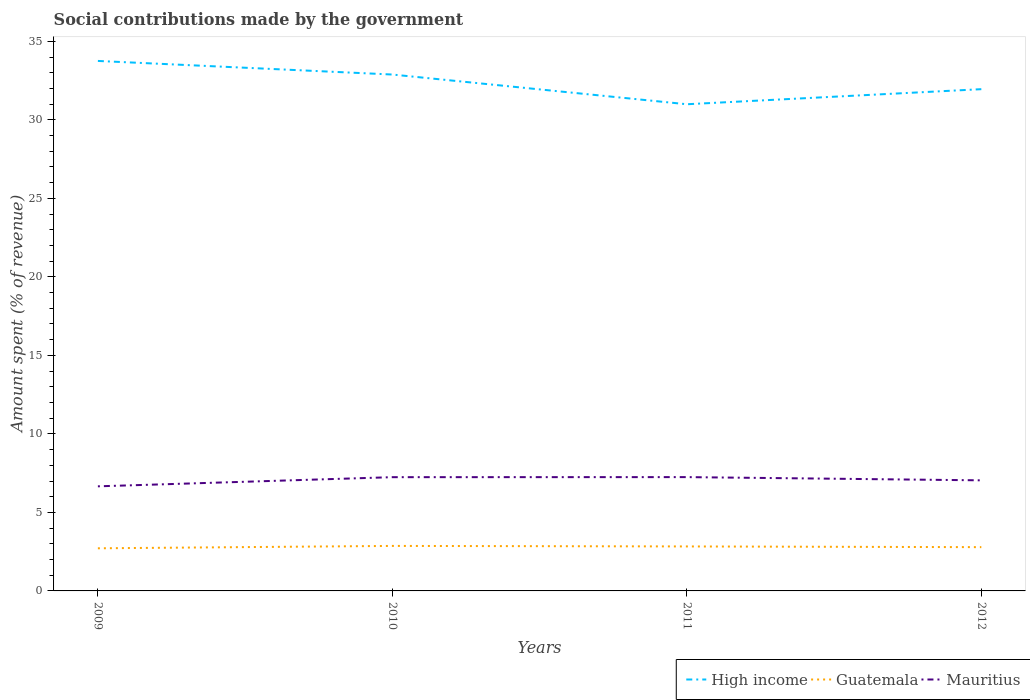Across all years, what is the maximum amount spent (in %) on social contributions in High income?
Your answer should be very brief. 31. In which year was the amount spent (in %) on social contributions in Guatemala maximum?
Offer a terse response. 2009. What is the total amount spent (in %) on social contributions in Mauritius in the graph?
Keep it short and to the point. -0.58. What is the difference between the highest and the second highest amount spent (in %) on social contributions in Mauritius?
Offer a terse response. 0.59. How many lines are there?
Your answer should be very brief. 3. How many years are there in the graph?
Offer a terse response. 4. What is the title of the graph?
Offer a terse response. Social contributions made by the government. Does "Sao Tome and Principe" appear as one of the legend labels in the graph?
Your response must be concise. No. What is the label or title of the Y-axis?
Provide a short and direct response. Amount spent (% of revenue). What is the Amount spent (% of revenue) in High income in 2009?
Offer a terse response. 33.75. What is the Amount spent (% of revenue) in Guatemala in 2009?
Make the answer very short. 2.71. What is the Amount spent (% of revenue) in Mauritius in 2009?
Provide a short and direct response. 6.66. What is the Amount spent (% of revenue) of High income in 2010?
Provide a short and direct response. 32.89. What is the Amount spent (% of revenue) of Guatemala in 2010?
Offer a terse response. 2.87. What is the Amount spent (% of revenue) in Mauritius in 2010?
Your answer should be very brief. 7.24. What is the Amount spent (% of revenue) of High income in 2011?
Offer a very short reply. 31. What is the Amount spent (% of revenue) in Guatemala in 2011?
Keep it short and to the point. 2.83. What is the Amount spent (% of revenue) in Mauritius in 2011?
Make the answer very short. 7.25. What is the Amount spent (% of revenue) of High income in 2012?
Keep it short and to the point. 31.96. What is the Amount spent (% of revenue) in Guatemala in 2012?
Ensure brevity in your answer.  2.79. What is the Amount spent (% of revenue) of Mauritius in 2012?
Offer a terse response. 7.04. Across all years, what is the maximum Amount spent (% of revenue) in High income?
Your answer should be compact. 33.75. Across all years, what is the maximum Amount spent (% of revenue) of Guatemala?
Your answer should be compact. 2.87. Across all years, what is the maximum Amount spent (% of revenue) in Mauritius?
Give a very brief answer. 7.25. Across all years, what is the minimum Amount spent (% of revenue) of High income?
Give a very brief answer. 31. Across all years, what is the minimum Amount spent (% of revenue) of Guatemala?
Ensure brevity in your answer.  2.71. Across all years, what is the minimum Amount spent (% of revenue) of Mauritius?
Your answer should be compact. 6.66. What is the total Amount spent (% of revenue) in High income in the graph?
Offer a very short reply. 129.59. What is the total Amount spent (% of revenue) in Guatemala in the graph?
Your answer should be compact. 11.2. What is the total Amount spent (% of revenue) of Mauritius in the graph?
Your answer should be compact. 28.2. What is the difference between the Amount spent (% of revenue) in High income in 2009 and that in 2010?
Provide a short and direct response. 0.87. What is the difference between the Amount spent (% of revenue) of Guatemala in 2009 and that in 2010?
Make the answer very short. -0.15. What is the difference between the Amount spent (% of revenue) of Mauritius in 2009 and that in 2010?
Give a very brief answer. -0.58. What is the difference between the Amount spent (% of revenue) in High income in 2009 and that in 2011?
Your answer should be compact. 2.76. What is the difference between the Amount spent (% of revenue) in Guatemala in 2009 and that in 2011?
Offer a terse response. -0.12. What is the difference between the Amount spent (% of revenue) of Mauritius in 2009 and that in 2011?
Give a very brief answer. -0.59. What is the difference between the Amount spent (% of revenue) in High income in 2009 and that in 2012?
Your response must be concise. 1.8. What is the difference between the Amount spent (% of revenue) of Guatemala in 2009 and that in 2012?
Your answer should be very brief. -0.07. What is the difference between the Amount spent (% of revenue) of Mauritius in 2009 and that in 2012?
Your answer should be compact. -0.38. What is the difference between the Amount spent (% of revenue) of High income in 2010 and that in 2011?
Provide a succinct answer. 1.89. What is the difference between the Amount spent (% of revenue) of Guatemala in 2010 and that in 2011?
Your answer should be very brief. 0.03. What is the difference between the Amount spent (% of revenue) in Mauritius in 2010 and that in 2011?
Provide a succinct answer. -0. What is the difference between the Amount spent (% of revenue) of High income in 2010 and that in 2012?
Your answer should be very brief. 0.93. What is the difference between the Amount spent (% of revenue) in Guatemala in 2010 and that in 2012?
Your response must be concise. 0.08. What is the difference between the Amount spent (% of revenue) of Mauritius in 2010 and that in 2012?
Provide a short and direct response. 0.2. What is the difference between the Amount spent (% of revenue) in High income in 2011 and that in 2012?
Give a very brief answer. -0.96. What is the difference between the Amount spent (% of revenue) in Guatemala in 2011 and that in 2012?
Make the answer very short. 0.05. What is the difference between the Amount spent (% of revenue) of Mauritius in 2011 and that in 2012?
Provide a short and direct response. 0.21. What is the difference between the Amount spent (% of revenue) in High income in 2009 and the Amount spent (% of revenue) in Guatemala in 2010?
Provide a short and direct response. 30.89. What is the difference between the Amount spent (% of revenue) of High income in 2009 and the Amount spent (% of revenue) of Mauritius in 2010?
Your response must be concise. 26.51. What is the difference between the Amount spent (% of revenue) of Guatemala in 2009 and the Amount spent (% of revenue) of Mauritius in 2010?
Keep it short and to the point. -4.53. What is the difference between the Amount spent (% of revenue) of High income in 2009 and the Amount spent (% of revenue) of Guatemala in 2011?
Provide a succinct answer. 30.92. What is the difference between the Amount spent (% of revenue) in High income in 2009 and the Amount spent (% of revenue) in Mauritius in 2011?
Offer a terse response. 26.51. What is the difference between the Amount spent (% of revenue) of Guatemala in 2009 and the Amount spent (% of revenue) of Mauritius in 2011?
Keep it short and to the point. -4.53. What is the difference between the Amount spent (% of revenue) of High income in 2009 and the Amount spent (% of revenue) of Guatemala in 2012?
Provide a succinct answer. 30.97. What is the difference between the Amount spent (% of revenue) in High income in 2009 and the Amount spent (% of revenue) in Mauritius in 2012?
Offer a terse response. 26.71. What is the difference between the Amount spent (% of revenue) in Guatemala in 2009 and the Amount spent (% of revenue) in Mauritius in 2012?
Offer a terse response. -4.33. What is the difference between the Amount spent (% of revenue) of High income in 2010 and the Amount spent (% of revenue) of Guatemala in 2011?
Your answer should be very brief. 30.06. What is the difference between the Amount spent (% of revenue) in High income in 2010 and the Amount spent (% of revenue) in Mauritius in 2011?
Ensure brevity in your answer.  25.64. What is the difference between the Amount spent (% of revenue) in Guatemala in 2010 and the Amount spent (% of revenue) in Mauritius in 2011?
Keep it short and to the point. -4.38. What is the difference between the Amount spent (% of revenue) of High income in 2010 and the Amount spent (% of revenue) of Guatemala in 2012?
Provide a short and direct response. 30.1. What is the difference between the Amount spent (% of revenue) of High income in 2010 and the Amount spent (% of revenue) of Mauritius in 2012?
Offer a very short reply. 25.84. What is the difference between the Amount spent (% of revenue) of Guatemala in 2010 and the Amount spent (% of revenue) of Mauritius in 2012?
Offer a terse response. -4.18. What is the difference between the Amount spent (% of revenue) in High income in 2011 and the Amount spent (% of revenue) in Guatemala in 2012?
Offer a very short reply. 28.21. What is the difference between the Amount spent (% of revenue) of High income in 2011 and the Amount spent (% of revenue) of Mauritius in 2012?
Your response must be concise. 23.95. What is the difference between the Amount spent (% of revenue) of Guatemala in 2011 and the Amount spent (% of revenue) of Mauritius in 2012?
Ensure brevity in your answer.  -4.21. What is the average Amount spent (% of revenue) in High income per year?
Your answer should be compact. 32.4. What is the average Amount spent (% of revenue) in Guatemala per year?
Your answer should be compact. 2.8. What is the average Amount spent (% of revenue) of Mauritius per year?
Offer a very short reply. 7.05. In the year 2009, what is the difference between the Amount spent (% of revenue) in High income and Amount spent (% of revenue) in Guatemala?
Provide a short and direct response. 31.04. In the year 2009, what is the difference between the Amount spent (% of revenue) in High income and Amount spent (% of revenue) in Mauritius?
Your answer should be very brief. 27.09. In the year 2009, what is the difference between the Amount spent (% of revenue) in Guatemala and Amount spent (% of revenue) in Mauritius?
Provide a short and direct response. -3.95. In the year 2010, what is the difference between the Amount spent (% of revenue) in High income and Amount spent (% of revenue) in Guatemala?
Make the answer very short. 30.02. In the year 2010, what is the difference between the Amount spent (% of revenue) of High income and Amount spent (% of revenue) of Mauritius?
Your answer should be compact. 25.64. In the year 2010, what is the difference between the Amount spent (% of revenue) in Guatemala and Amount spent (% of revenue) in Mauritius?
Make the answer very short. -4.38. In the year 2011, what is the difference between the Amount spent (% of revenue) of High income and Amount spent (% of revenue) of Guatemala?
Make the answer very short. 28.16. In the year 2011, what is the difference between the Amount spent (% of revenue) in High income and Amount spent (% of revenue) in Mauritius?
Ensure brevity in your answer.  23.75. In the year 2011, what is the difference between the Amount spent (% of revenue) of Guatemala and Amount spent (% of revenue) of Mauritius?
Provide a succinct answer. -4.42. In the year 2012, what is the difference between the Amount spent (% of revenue) of High income and Amount spent (% of revenue) of Guatemala?
Your answer should be very brief. 29.17. In the year 2012, what is the difference between the Amount spent (% of revenue) in High income and Amount spent (% of revenue) in Mauritius?
Provide a short and direct response. 24.91. In the year 2012, what is the difference between the Amount spent (% of revenue) of Guatemala and Amount spent (% of revenue) of Mauritius?
Your answer should be compact. -4.26. What is the ratio of the Amount spent (% of revenue) of High income in 2009 to that in 2010?
Your response must be concise. 1.03. What is the ratio of the Amount spent (% of revenue) of Guatemala in 2009 to that in 2010?
Keep it short and to the point. 0.95. What is the ratio of the Amount spent (% of revenue) of Mauritius in 2009 to that in 2010?
Provide a succinct answer. 0.92. What is the ratio of the Amount spent (% of revenue) of High income in 2009 to that in 2011?
Keep it short and to the point. 1.09. What is the ratio of the Amount spent (% of revenue) of Guatemala in 2009 to that in 2011?
Provide a succinct answer. 0.96. What is the ratio of the Amount spent (% of revenue) in Mauritius in 2009 to that in 2011?
Provide a short and direct response. 0.92. What is the ratio of the Amount spent (% of revenue) of High income in 2009 to that in 2012?
Provide a short and direct response. 1.06. What is the ratio of the Amount spent (% of revenue) of Guatemala in 2009 to that in 2012?
Make the answer very short. 0.97. What is the ratio of the Amount spent (% of revenue) in Mauritius in 2009 to that in 2012?
Provide a succinct answer. 0.95. What is the ratio of the Amount spent (% of revenue) in High income in 2010 to that in 2011?
Provide a succinct answer. 1.06. What is the ratio of the Amount spent (% of revenue) of Guatemala in 2010 to that in 2011?
Provide a short and direct response. 1.01. What is the ratio of the Amount spent (% of revenue) in Mauritius in 2010 to that in 2011?
Offer a terse response. 1. What is the ratio of the Amount spent (% of revenue) in High income in 2010 to that in 2012?
Make the answer very short. 1.03. What is the ratio of the Amount spent (% of revenue) of Guatemala in 2010 to that in 2012?
Provide a short and direct response. 1.03. What is the ratio of the Amount spent (% of revenue) in Mauritius in 2010 to that in 2012?
Provide a succinct answer. 1.03. What is the ratio of the Amount spent (% of revenue) in High income in 2011 to that in 2012?
Ensure brevity in your answer.  0.97. What is the ratio of the Amount spent (% of revenue) of Guatemala in 2011 to that in 2012?
Give a very brief answer. 1.02. What is the ratio of the Amount spent (% of revenue) in Mauritius in 2011 to that in 2012?
Provide a succinct answer. 1.03. What is the difference between the highest and the second highest Amount spent (% of revenue) in High income?
Your response must be concise. 0.87. What is the difference between the highest and the second highest Amount spent (% of revenue) in Guatemala?
Keep it short and to the point. 0.03. What is the difference between the highest and the second highest Amount spent (% of revenue) in Mauritius?
Provide a short and direct response. 0. What is the difference between the highest and the lowest Amount spent (% of revenue) in High income?
Your answer should be compact. 2.76. What is the difference between the highest and the lowest Amount spent (% of revenue) of Guatemala?
Keep it short and to the point. 0.15. What is the difference between the highest and the lowest Amount spent (% of revenue) in Mauritius?
Give a very brief answer. 0.59. 